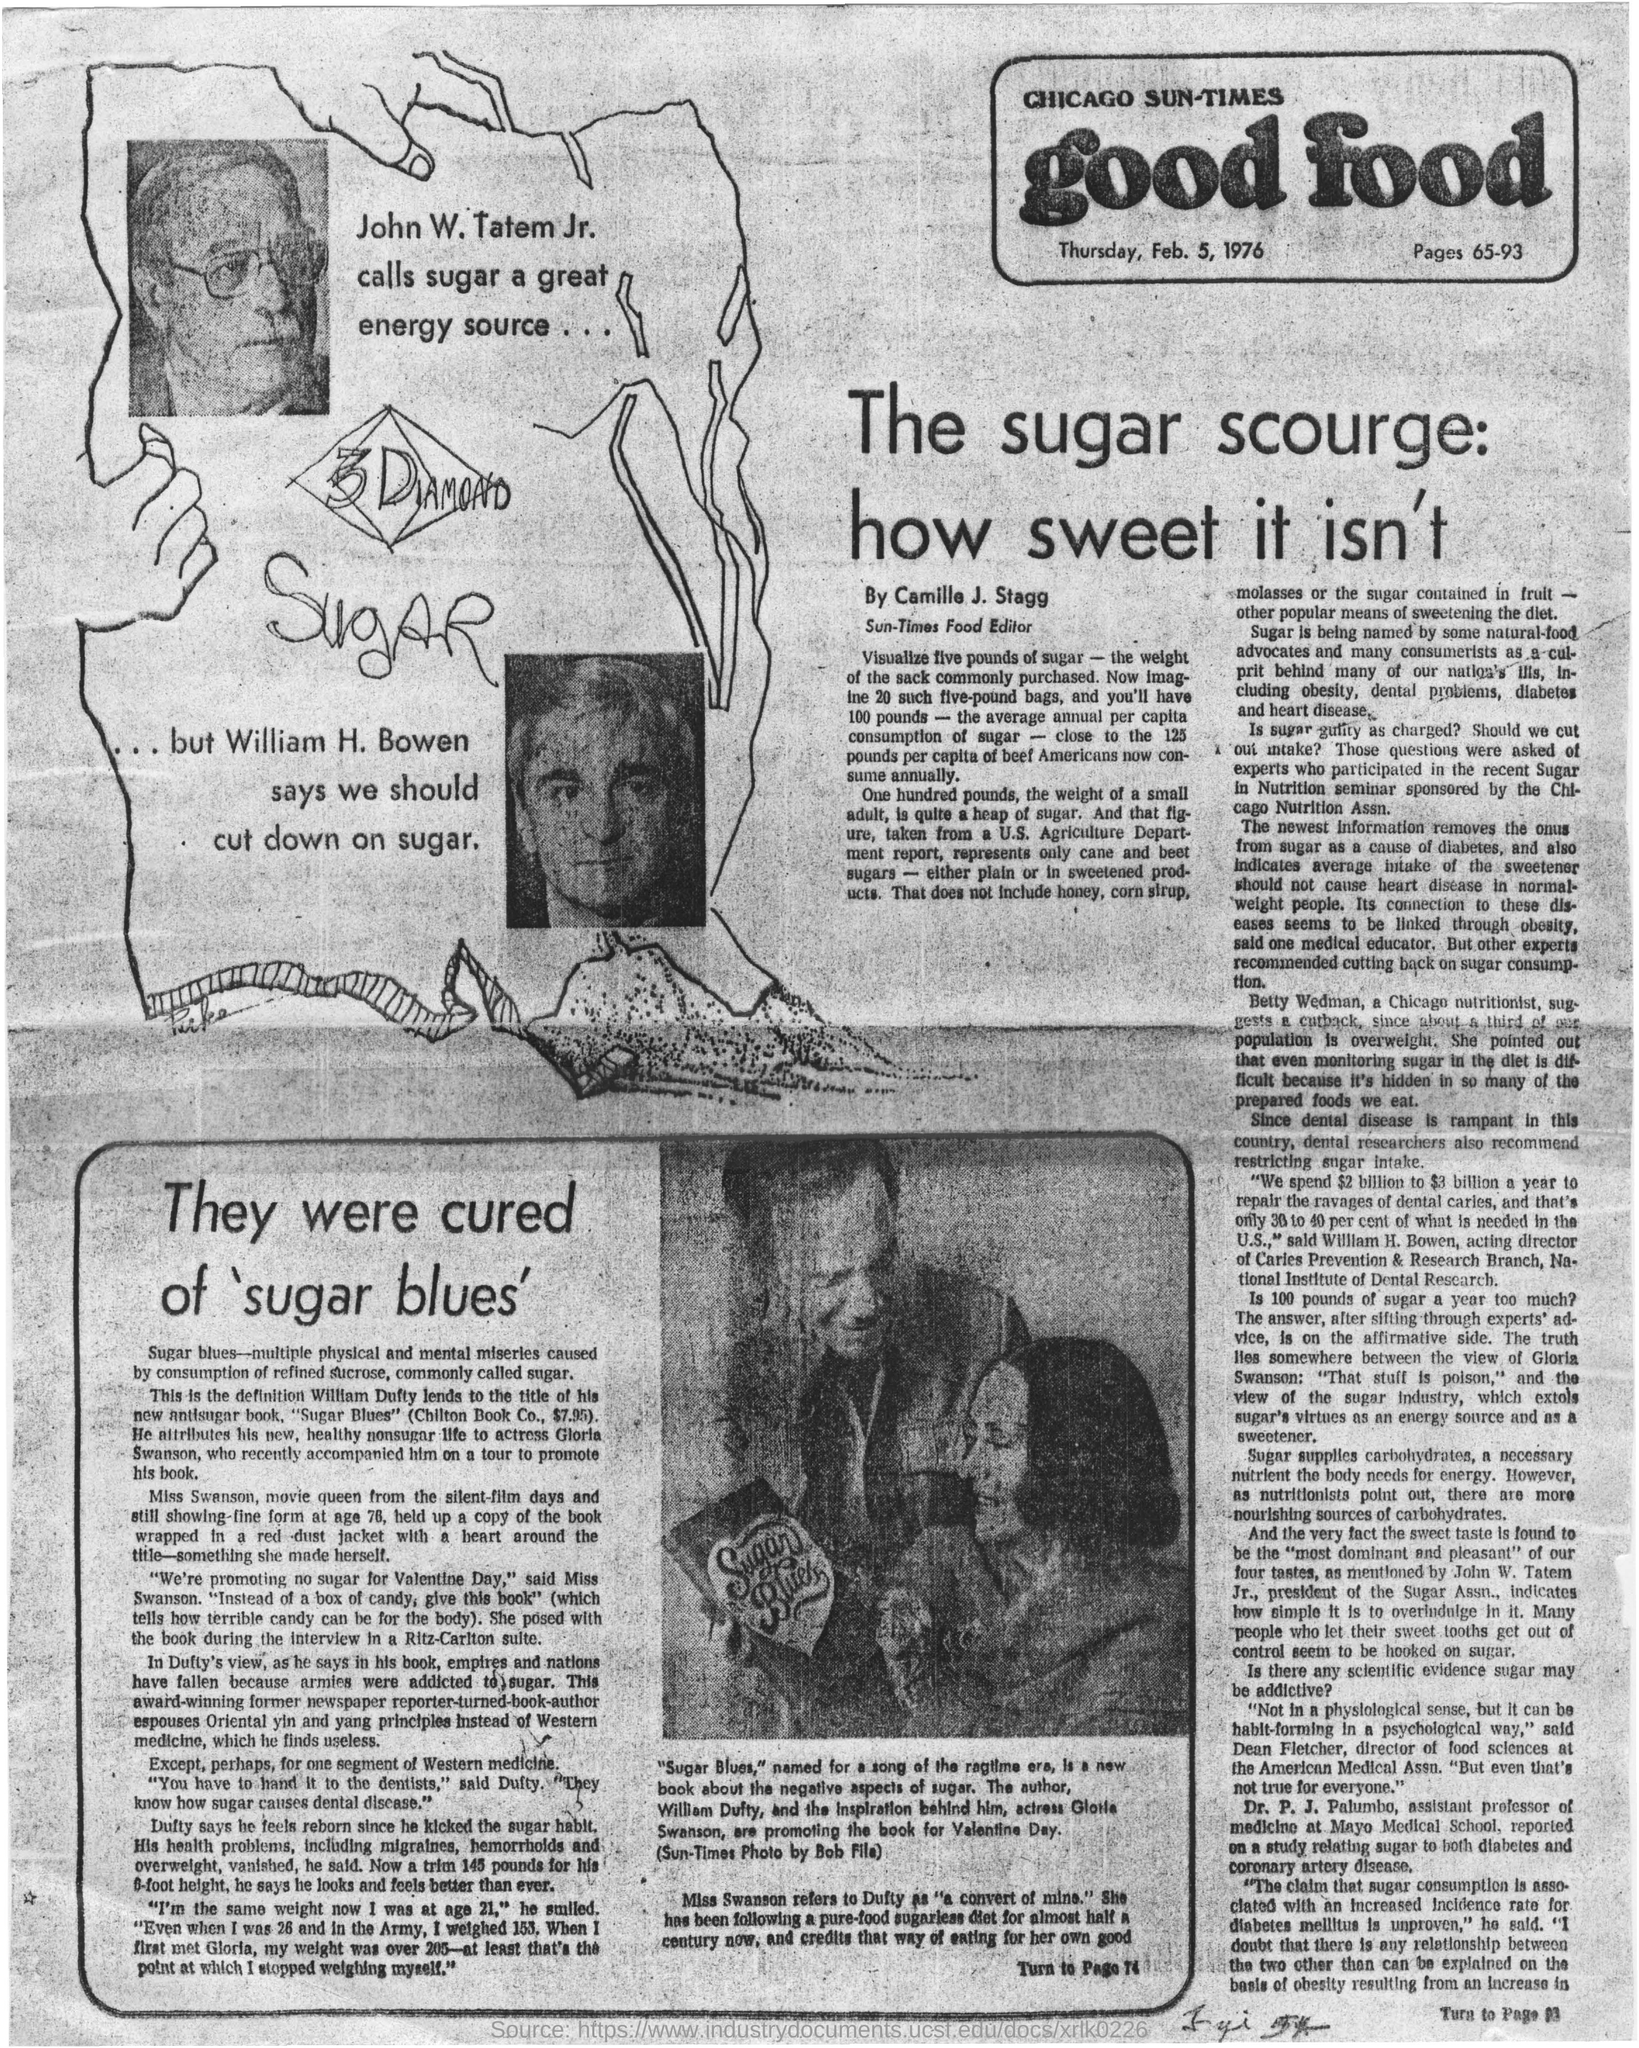Mention a couple of crucial points in this snapshot. Camille J. Stagg is the food editor of the Sun-Times. William H. Bowen stated that we should reduce our consumption of sugar. The date mentioned in the newspaper is Thursday, Feb. 5, 1976. William H. Bowen suggests that we should limit our intake of sugar. The American Medical Association has a director of food sciences named Dean Fletcher. 